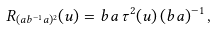<formula> <loc_0><loc_0><loc_500><loc_500>R _ { ( a b ^ { - 1 } a ) ^ { 2 } } ( u ) = b a \, \tau ^ { 2 } ( u ) \, ( b a ) ^ { - 1 } \, ,</formula> 